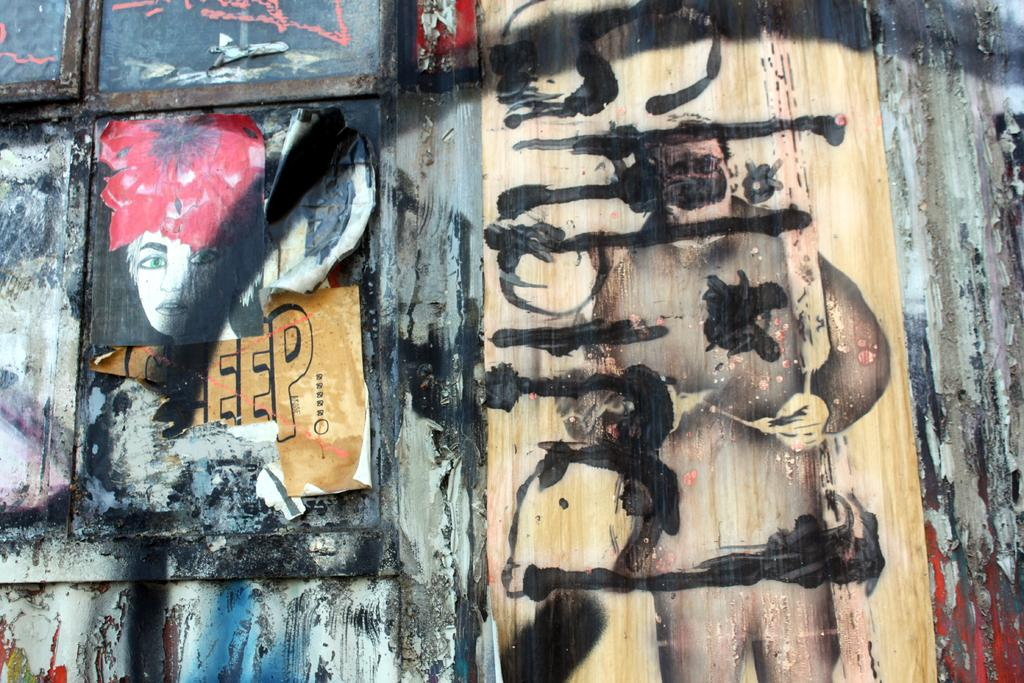What is on the window in the image? There are posts on the window in the image. What can be seen on the wall in the image? There is text visible on the wall in the image. How many fingers can be seen pointing at the text on the wall in the image? There are no fingers visible in the image, so it is not possible to determine how many fingers might be pointing at the text. 